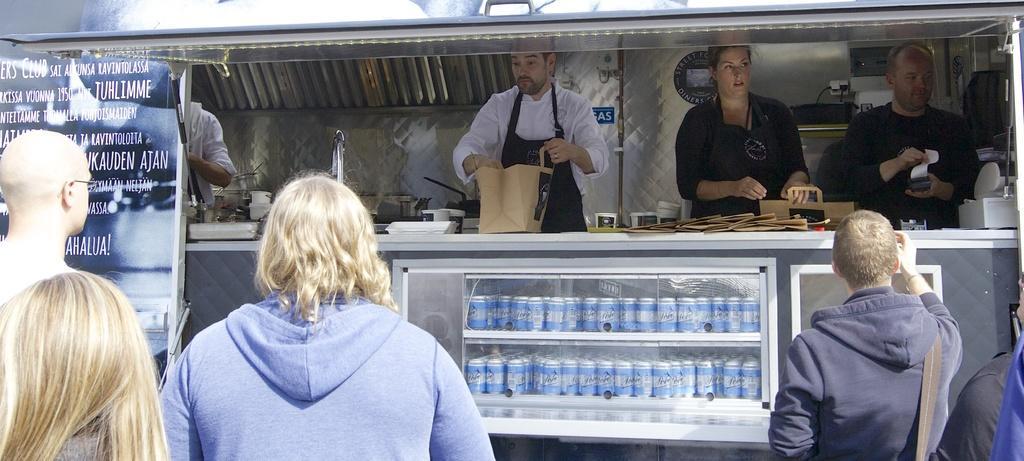Could you give a brief overview of what you see in this image? In this image there is a desk having a tap, bags, machine and few objects are on it. Behind the desk few persons are standing. A person wearing a white shirt is wearing apron. He is holding a bag. Beside there is a woman wearing apron is holding a bag. Right side there is a person holding a machine. Bottom of image there are few persons. Left side there is a banner. 